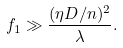Convert formula to latex. <formula><loc_0><loc_0><loc_500><loc_500>f _ { 1 } \gg \frac { ( \eta D / n ) ^ { 2 } } { \lambda } .</formula> 